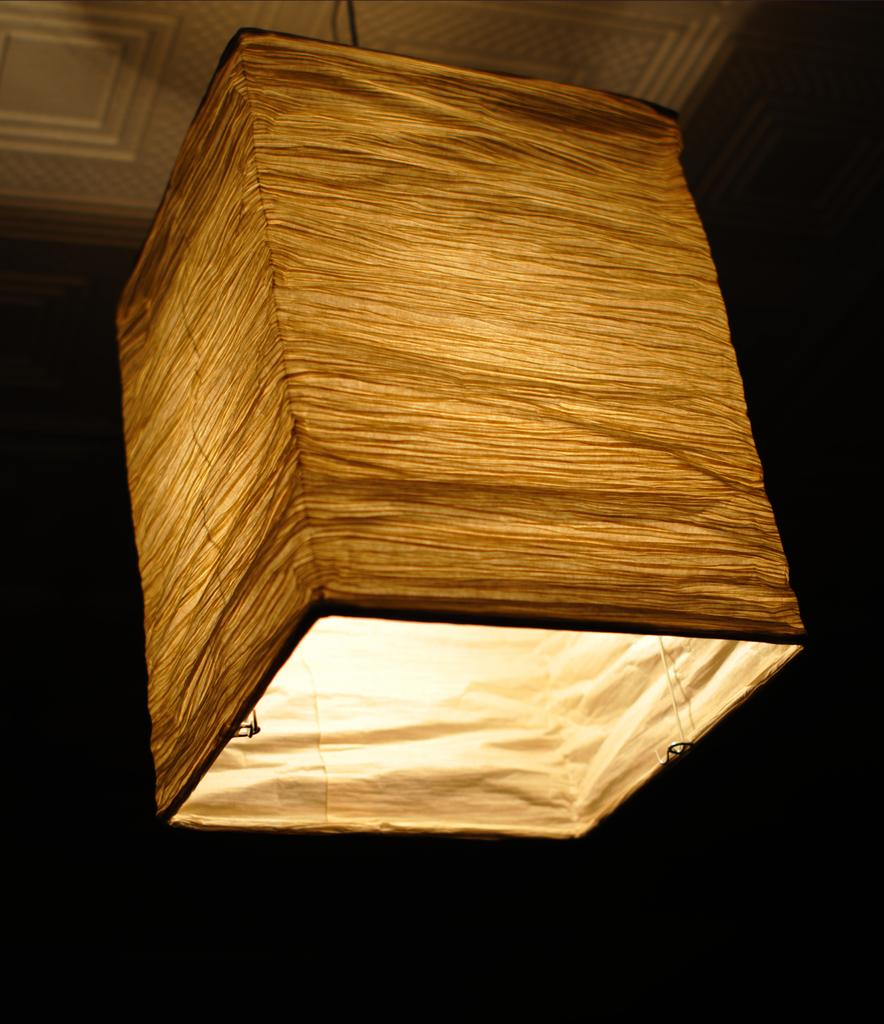What is the setting of the image? The image is of a room. What is covering the light in the room? There is a cloth around the light in the room. What part of the room's structure can be seen in the image? The ceiling is visible in the image. What type of skate is being used in the room? There is no skate present in the image; it is a room with a cloth-covered light and a visible ceiling. 